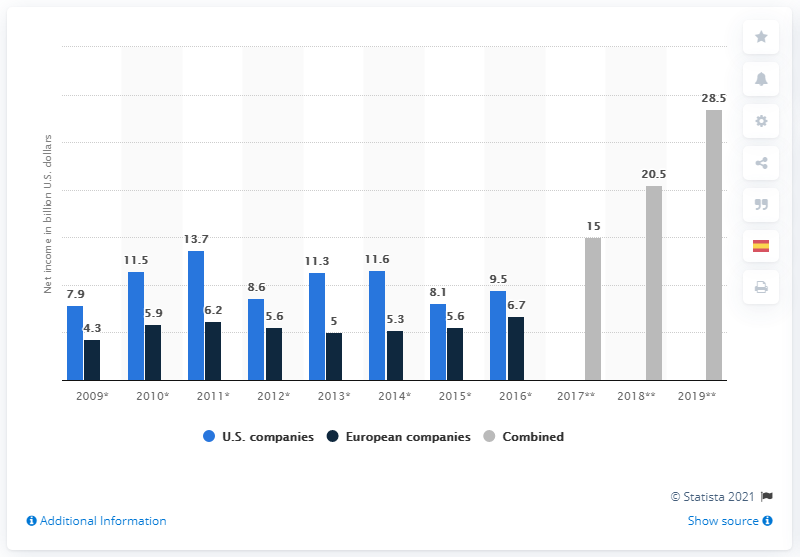What's the total net income in total from 2009 to 2010 of European companies? The total net income for European companies from 2009 to 2010 is the sum of the individual net incomes for each year; for 2009, it's approximately $4.3 billion, and for 2010, it's around $5.9 billion, resulting in an aggregate two-year total of about $10.2 billion. 